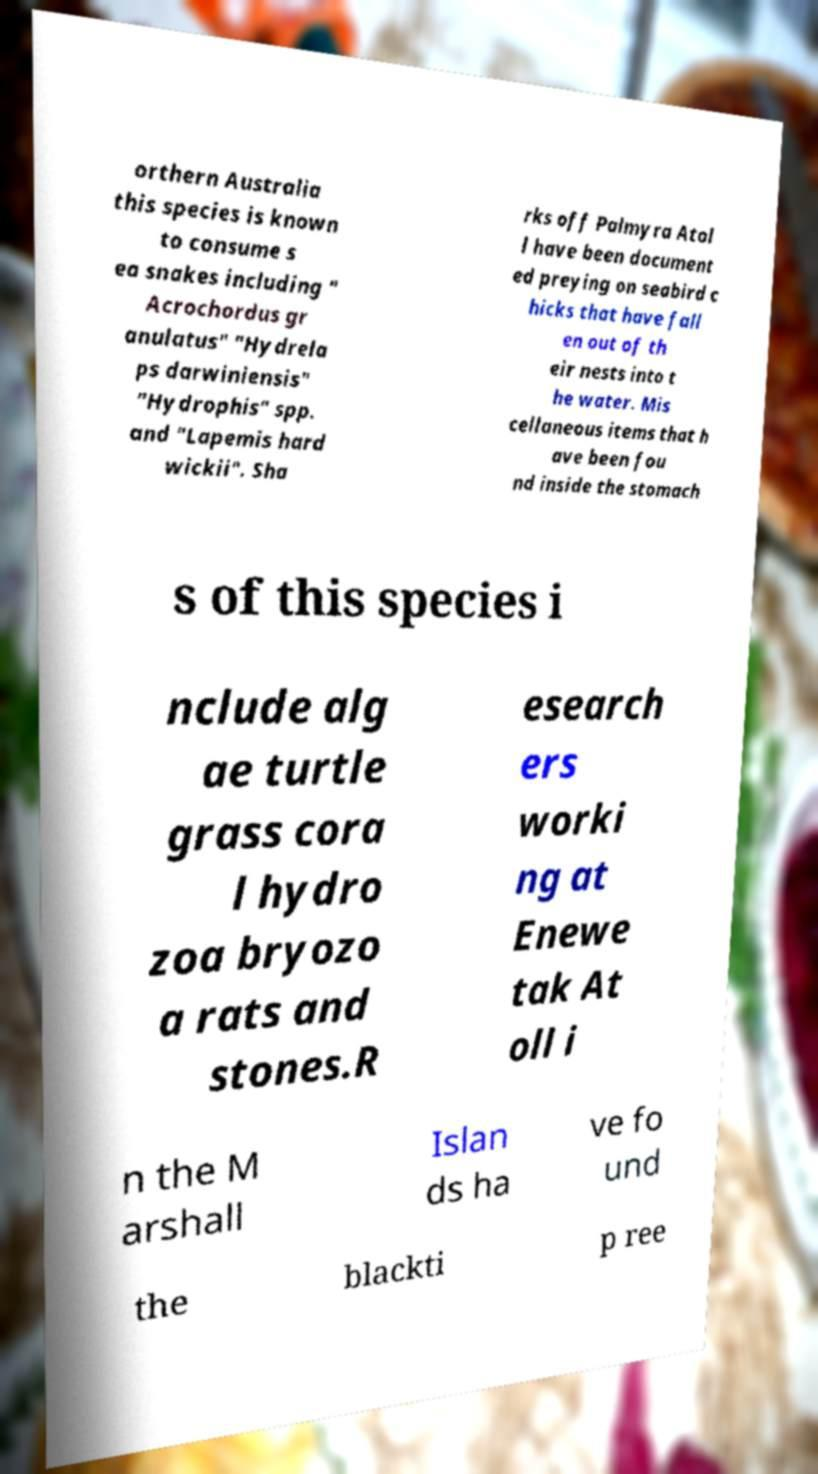Please read and relay the text visible in this image. What does it say? orthern Australia this species is known to consume s ea snakes including " Acrochordus gr anulatus" "Hydrela ps darwiniensis" "Hydrophis" spp. and "Lapemis hard wickii". Sha rks off Palmyra Atol l have been document ed preying on seabird c hicks that have fall en out of th eir nests into t he water. Mis cellaneous items that h ave been fou nd inside the stomach s of this species i nclude alg ae turtle grass cora l hydro zoa bryozo a rats and stones.R esearch ers worki ng at Enewe tak At oll i n the M arshall Islan ds ha ve fo und the blackti p ree 